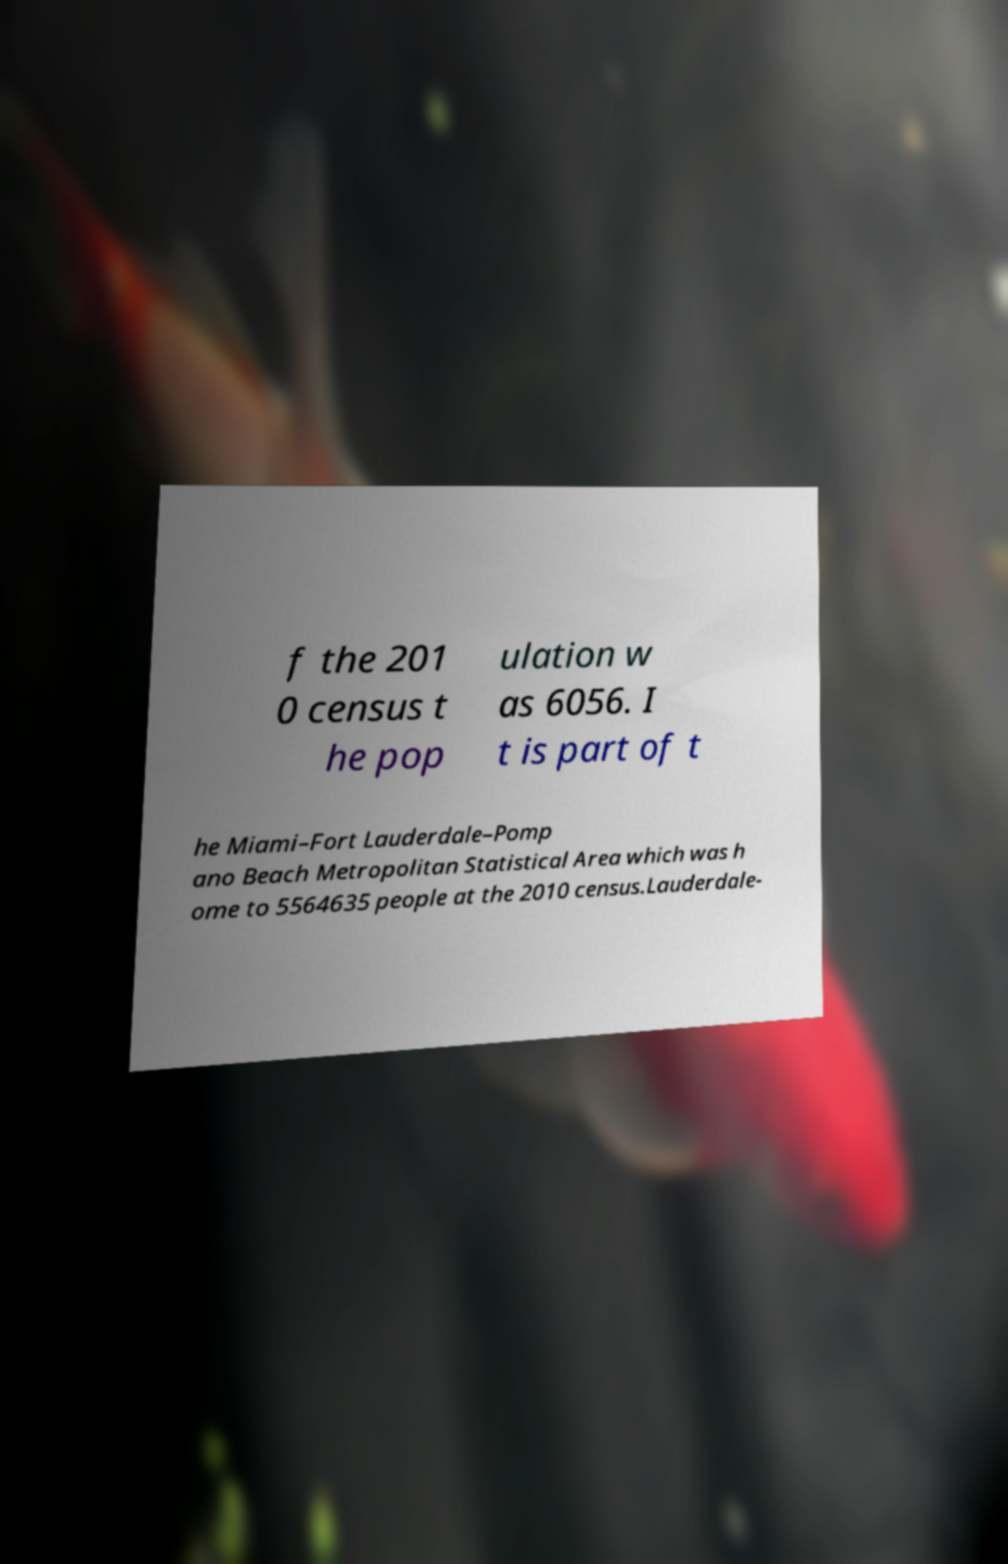What messages or text are displayed in this image? I need them in a readable, typed format. f the 201 0 census t he pop ulation w as 6056. I t is part of t he Miami–Fort Lauderdale–Pomp ano Beach Metropolitan Statistical Area which was h ome to 5564635 people at the 2010 census.Lauderdale- 